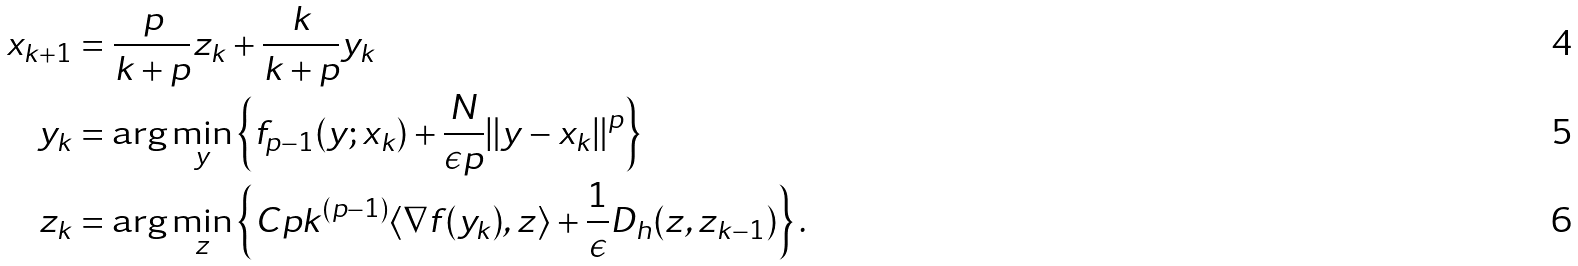<formula> <loc_0><loc_0><loc_500><loc_500>x _ { k + 1 } & = \frac { p } { k + p } z _ { k } + \frac { k } { k + p } y _ { k } \\ y _ { k } & = \arg \min _ { y } \left \{ f _ { p - 1 } ( y ; x _ { k } ) + \frac { N } { \epsilon p } \| y - x _ { k } \| ^ { p } \right \} \\ z _ { k } & = \arg \min _ { z } \left \{ C p k ^ { ( p - 1 ) } \langle \nabla f ( y _ { k } ) , z \rangle + \frac { 1 } { \epsilon } D _ { h } ( z , z _ { k - 1 } ) \right \} .</formula> 